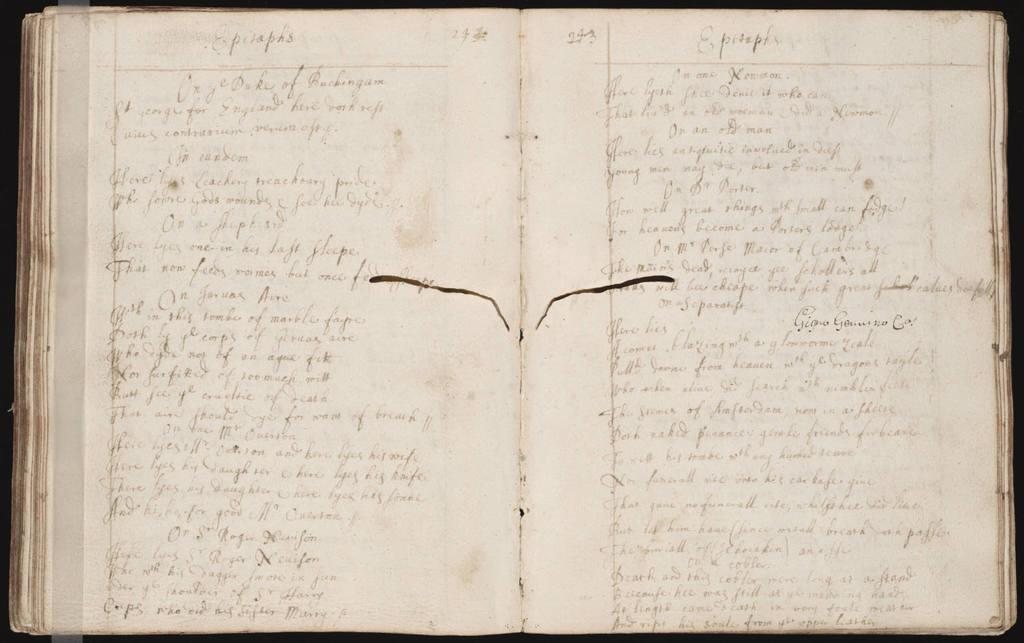Provide a one-sentence caption for the provided image. An open notebook with pages written in cursive writing fill the pages mentioning feelings about people as if this is a diary. 